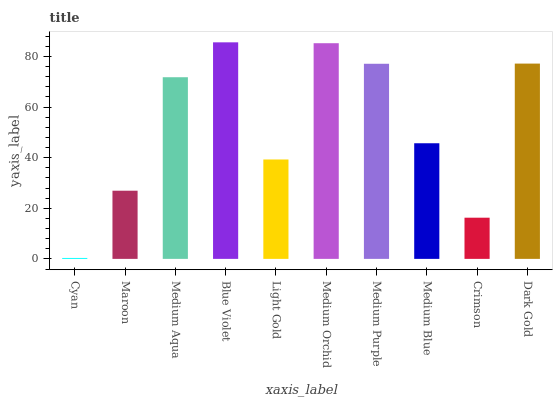Is Cyan the minimum?
Answer yes or no. Yes. Is Blue Violet the maximum?
Answer yes or no. Yes. Is Maroon the minimum?
Answer yes or no. No. Is Maroon the maximum?
Answer yes or no. No. Is Maroon greater than Cyan?
Answer yes or no. Yes. Is Cyan less than Maroon?
Answer yes or no. Yes. Is Cyan greater than Maroon?
Answer yes or no. No. Is Maroon less than Cyan?
Answer yes or no. No. Is Medium Aqua the high median?
Answer yes or no. Yes. Is Medium Blue the low median?
Answer yes or no. Yes. Is Dark Gold the high median?
Answer yes or no. No. Is Medium Aqua the low median?
Answer yes or no. No. 